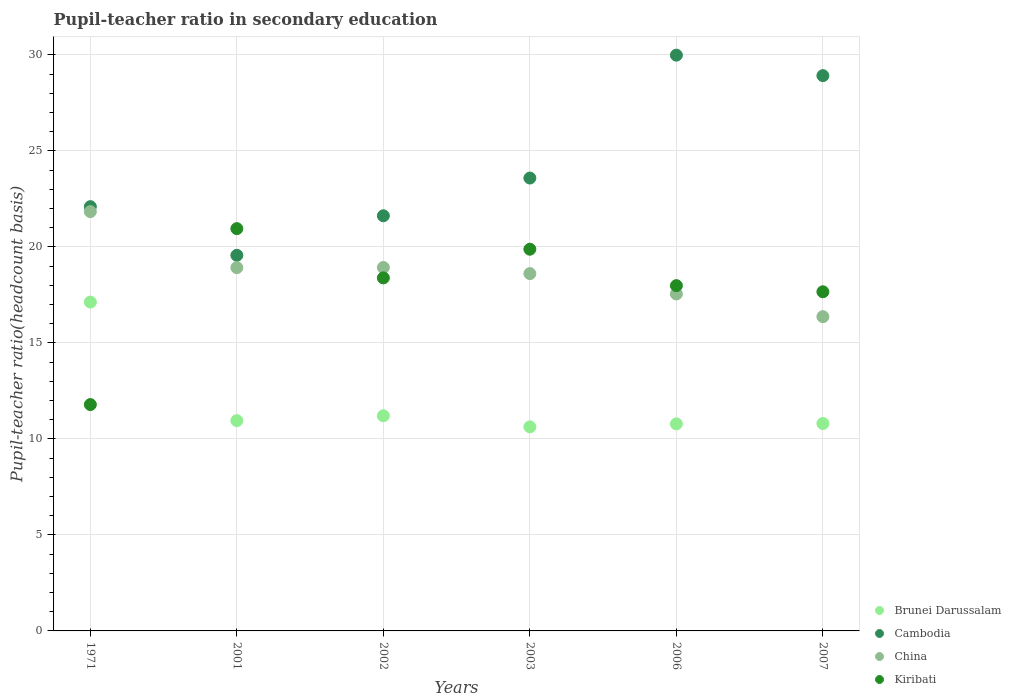Is the number of dotlines equal to the number of legend labels?
Make the answer very short. Yes. What is the pupil-teacher ratio in secondary education in Kiribati in 1971?
Ensure brevity in your answer.  11.79. Across all years, what is the maximum pupil-teacher ratio in secondary education in Cambodia?
Keep it short and to the point. 29.99. Across all years, what is the minimum pupil-teacher ratio in secondary education in China?
Offer a terse response. 16.37. What is the total pupil-teacher ratio in secondary education in Cambodia in the graph?
Ensure brevity in your answer.  145.78. What is the difference between the pupil-teacher ratio in secondary education in China in 2006 and that in 2007?
Your response must be concise. 1.18. What is the difference between the pupil-teacher ratio in secondary education in China in 2006 and the pupil-teacher ratio in secondary education in Kiribati in 1971?
Ensure brevity in your answer.  5.76. What is the average pupil-teacher ratio in secondary education in Cambodia per year?
Offer a terse response. 24.3. In the year 2003, what is the difference between the pupil-teacher ratio in secondary education in China and pupil-teacher ratio in secondary education in Cambodia?
Your answer should be compact. -4.98. In how many years, is the pupil-teacher ratio in secondary education in Cambodia greater than 24?
Provide a succinct answer. 2. What is the ratio of the pupil-teacher ratio in secondary education in Kiribati in 2001 to that in 2007?
Provide a short and direct response. 1.19. Is the pupil-teacher ratio in secondary education in China in 2001 less than that in 2007?
Provide a short and direct response. No. What is the difference between the highest and the second highest pupil-teacher ratio in secondary education in Kiribati?
Provide a succinct answer. 1.07. What is the difference between the highest and the lowest pupil-teacher ratio in secondary education in Brunei Darussalam?
Offer a very short reply. 6.5. Is the sum of the pupil-teacher ratio in secondary education in China in 2001 and 2003 greater than the maximum pupil-teacher ratio in secondary education in Kiribati across all years?
Your answer should be compact. Yes. Is it the case that in every year, the sum of the pupil-teacher ratio in secondary education in Cambodia and pupil-teacher ratio in secondary education in China  is greater than the sum of pupil-teacher ratio in secondary education in Brunei Darussalam and pupil-teacher ratio in secondary education in Kiribati?
Your answer should be very brief. No. Is the pupil-teacher ratio in secondary education in Brunei Darussalam strictly less than the pupil-teacher ratio in secondary education in Cambodia over the years?
Make the answer very short. Yes. How many years are there in the graph?
Provide a short and direct response. 6. How many legend labels are there?
Make the answer very short. 4. How are the legend labels stacked?
Provide a succinct answer. Vertical. What is the title of the graph?
Your response must be concise. Pupil-teacher ratio in secondary education. Does "Czech Republic" appear as one of the legend labels in the graph?
Your answer should be compact. No. What is the label or title of the Y-axis?
Provide a succinct answer. Pupil-teacher ratio(headcount basis). What is the Pupil-teacher ratio(headcount basis) in Brunei Darussalam in 1971?
Your answer should be compact. 17.13. What is the Pupil-teacher ratio(headcount basis) of Cambodia in 1971?
Provide a short and direct response. 22.1. What is the Pupil-teacher ratio(headcount basis) in China in 1971?
Give a very brief answer. 21.84. What is the Pupil-teacher ratio(headcount basis) of Kiribati in 1971?
Offer a terse response. 11.79. What is the Pupil-teacher ratio(headcount basis) in Brunei Darussalam in 2001?
Make the answer very short. 10.95. What is the Pupil-teacher ratio(headcount basis) of Cambodia in 2001?
Make the answer very short. 19.56. What is the Pupil-teacher ratio(headcount basis) in China in 2001?
Offer a terse response. 18.92. What is the Pupil-teacher ratio(headcount basis) of Kiribati in 2001?
Provide a short and direct response. 20.95. What is the Pupil-teacher ratio(headcount basis) in Brunei Darussalam in 2002?
Your answer should be compact. 11.21. What is the Pupil-teacher ratio(headcount basis) of Cambodia in 2002?
Provide a short and direct response. 21.62. What is the Pupil-teacher ratio(headcount basis) in China in 2002?
Ensure brevity in your answer.  18.93. What is the Pupil-teacher ratio(headcount basis) of Kiribati in 2002?
Make the answer very short. 18.39. What is the Pupil-teacher ratio(headcount basis) of Brunei Darussalam in 2003?
Provide a short and direct response. 10.63. What is the Pupil-teacher ratio(headcount basis) in Cambodia in 2003?
Provide a succinct answer. 23.59. What is the Pupil-teacher ratio(headcount basis) in China in 2003?
Offer a terse response. 18.61. What is the Pupil-teacher ratio(headcount basis) in Kiribati in 2003?
Provide a succinct answer. 19.88. What is the Pupil-teacher ratio(headcount basis) in Brunei Darussalam in 2006?
Your answer should be compact. 10.78. What is the Pupil-teacher ratio(headcount basis) of Cambodia in 2006?
Offer a very short reply. 29.99. What is the Pupil-teacher ratio(headcount basis) of China in 2006?
Your answer should be compact. 17.55. What is the Pupil-teacher ratio(headcount basis) of Kiribati in 2006?
Provide a succinct answer. 17.98. What is the Pupil-teacher ratio(headcount basis) in Brunei Darussalam in 2007?
Provide a short and direct response. 10.8. What is the Pupil-teacher ratio(headcount basis) of Cambodia in 2007?
Provide a short and direct response. 28.92. What is the Pupil-teacher ratio(headcount basis) of China in 2007?
Give a very brief answer. 16.37. What is the Pupil-teacher ratio(headcount basis) in Kiribati in 2007?
Offer a terse response. 17.66. Across all years, what is the maximum Pupil-teacher ratio(headcount basis) of Brunei Darussalam?
Your answer should be very brief. 17.13. Across all years, what is the maximum Pupil-teacher ratio(headcount basis) in Cambodia?
Provide a short and direct response. 29.99. Across all years, what is the maximum Pupil-teacher ratio(headcount basis) in China?
Your answer should be very brief. 21.84. Across all years, what is the maximum Pupil-teacher ratio(headcount basis) of Kiribati?
Make the answer very short. 20.95. Across all years, what is the minimum Pupil-teacher ratio(headcount basis) of Brunei Darussalam?
Your answer should be compact. 10.63. Across all years, what is the minimum Pupil-teacher ratio(headcount basis) of Cambodia?
Provide a succinct answer. 19.56. Across all years, what is the minimum Pupil-teacher ratio(headcount basis) of China?
Give a very brief answer. 16.37. Across all years, what is the minimum Pupil-teacher ratio(headcount basis) in Kiribati?
Your answer should be compact. 11.79. What is the total Pupil-teacher ratio(headcount basis) in Brunei Darussalam in the graph?
Your answer should be very brief. 71.5. What is the total Pupil-teacher ratio(headcount basis) in Cambodia in the graph?
Your answer should be compact. 145.78. What is the total Pupil-teacher ratio(headcount basis) in China in the graph?
Offer a very short reply. 112.22. What is the total Pupil-teacher ratio(headcount basis) of Kiribati in the graph?
Your response must be concise. 106.66. What is the difference between the Pupil-teacher ratio(headcount basis) of Brunei Darussalam in 1971 and that in 2001?
Provide a short and direct response. 6.18. What is the difference between the Pupil-teacher ratio(headcount basis) of Cambodia in 1971 and that in 2001?
Provide a short and direct response. 2.53. What is the difference between the Pupil-teacher ratio(headcount basis) in China in 1971 and that in 2001?
Your answer should be compact. 2.92. What is the difference between the Pupil-teacher ratio(headcount basis) in Kiribati in 1971 and that in 2001?
Ensure brevity in your answer.  -9.16. What is the difference between the Pupil-teacher ratio(headcount basis) of Brunei Darussalam in 1971 and that in 2002?
Give a very brief answer. 5.92. What is the difference between the Pupil-teacher ratio(headcount basis) in Cambodia in 1971 and that in 2002?
Offer a very short reply. 0.47. What is the difference between the Pupil-teacher ratio(headcount basis) of China in 1971 and that in 2002?
Your answer should be very brief. 2.91. What is the difference between the Pupil-teacher ratio(headcount basis) in Kiribati in 1971 and that in 2002?
Provide a succinct answer. -6.6. What is the difference between the Pupil-teacher ratio(headcount basis) of Brunei Darussalam in 1971 and that in 2003?
Keep it short and to the point. 6.5. What is the difference between the Pupil-teacher ratio(headcount basis) in Cambodia in 1971 and that in 2003?
Your answer should be compact. -1.49. What is the difference between the Pupil-teacher ratio(headcount basis) of China in 1971 and that in 2003?
Make the answer very short. 3.23. What is the difference between the Pupil-teacher ratio(headcount basis) in Kiribati in 1971 and that in 2003?
Your answer should be very brief. -8.09. What is the difference between the Pupil-teacher ratio(headcount basis) in Brunei Darussalam in 1971 and that in 2006?
Your answer should be compact. 6.34. What is the difference between the Pupil-teacher ratio(headcount basis) of Cambodia in 1971 and that in 2006?
Make the answer very short. -7.89. What is the difference between the Pupil-teacher ratio(headcount basis) of China in 1971 and that in 2006?
Offer a very short reply. 4.29. What is the difference between the Pupil-teacher ratio(headcount basis) of Kiribati in 1971 and that in 2006?
Your answer should be very brief. -6.19. What is the difference between the Pupil-teacher ratio(headcount basis) of Brunei Darussalam in 1971 and that in 2007?
Keep it short and to the point. 6.32. What is the difference between the Pupil-teacher ratio(headcount basis) in Cambodia in 1971 and that in 2007?
Offer a very short reply. -6.82. What is the difference between the Pupil-teacher ratio(headcount basis) of China in 1971 and that in 2007?
Give a very brief answer. 5.47. What is the difference between the Pupil-teacher ratio(headcount basis) in Kiribati in 1971 and that in 2007?
Keep it short and to the point. -5.88. What is the difference between the Pupil-teacher ratio(headcount basis) of Brunei Darussalam in 2001 and that in 2002?
Your answer should be compact. -0.25. What is the difference between the Pupil-teacher ratio(headcount basis) in Cambodia in 2001 and that in 2002?
Provide a short and direct response. -2.06. What is the difference between the Pupil-teacher ratio(headcount basis) of China in 2001 and that in 2002?
Provide a short and direct response. -0.01. What is the difference between the Pupil-teacher ratio(headcount basis) of Kiribati in 2001 and that in 2002?
Make the answer very short. 2.57. What is the difference between the Pupil-teacher ratio(headcount basis) of Brunei Darussalam in 2001 and that in 2003?
Your answer should be very brief. 0.32. What is the difference between the Pupil-teacher ratio(headcount basis) in Cambodia in 2001 and that in 2003?
Offer a terse response. -4.02. What is the difference between the Pupil-teacher ratio(headcount basis) in China in 2001 and that in 2003?
Keep it short and to the point. 0.31. What is the difference between the Pupil-teacher ratio(headcount basis) in Kiribati in 2001 and that in 2003?
Make the answer very short. 1.07. What is the difference between the Pupil-teacher ratio(headcount basis) in Brunei Darussalam in 2001 and that in 2006?
Ensure brevity in your answer.  0.17. What is the difference between the Pupil-teacher ratio(headcount basis) of Cambodia in 2001 and that in 2006?
Keep it short and to the point. -10.42. What is the difference between the Pupil-teacher ratio(headcount basis) in China in 2001 and that in 2006?
Give a very brief answer. 1.37. What is the difference between the Pupil-teacher ratio(headcount basis) in Kiribati in 2001 and that in 2006?
Keep it short and to the point. 2.97. What is the difference between the Pupil-teacher ratio(headcount basis) of Brunei Darussalam in 2001 and that in 2007?
Provide a short and direct response. 0.15. What is the difference between the Pupil-teacher ratio(headcount basis) in Cambodia in 2001 and that in 2007?
Offer a terse response. -9.36. What is the difference between the Pupil-teacher ratio(headcount basis) in China in 2001 and that in 2007?
Ensure brevity in your answer.  2.55. What is the difference between the Pupil-teacher ratio(headcount basis) of Kiribati in 2001 and that in 2007?
Your answer should be compact. 3.29. What is the difference between the Pupil-teacher ratio(headcount basis) of Brunei Darussalam in 2002 and that in 2003?
Your answer should be very brief. 0.58. What is the difference between the Pupil-teacher ratio(headcount basis) of Cambodia in 2002 and that in 2003?
Provide a short and direct response. -1.97. What is the difference between the Pupil-teacher ratio(headcount basis) of China in 2002 and that in 2003?
Offer a terse response. 0.32. What is the difference between the Pupil-teacher ratio(headcount basis) of Kiribati in 2002 and that in 2003?
Provide a short and direct response. -1.49. What is the difference between the Pupil-teacher ratio(headcount basis) in Brunei Darussalam in 2002 and that in 2006?
Provide a short and direct response. 0.42. What is the difference between the Pupil-teacher ratio(headcount basis) in Cambodia in 2002 and that in 2006?
Your response must be concise. -8.37. What is the difference between the Pupil-teacher ratio(headcount basis) in China in 2002 and that in 2006?
Provide a short and direct response. 1.38. What is the difference between the Pupil-teacher ratio(headcount basis) of Kiribati in 2002 and that in 2006?
Provide a short and direct response. 0.4. What is the difference between the Pupil-teacher ratio(headcount basis) of Brunei Darussalam in 2002 and that in 2007?
Your response must be concise. 0.4. What is the difference between the Pupil-teacher ratio(headcount basis) of Cambodia in 2002 and that in 2007?
Provide a short and direct response. -7.3. What is the difference between the Pupil-teacher ratio(headcount basis) of China in 2002 and that in 2007?
Give a very brief answer. 2.56. What is the difference between the Pupil-teacher ratio(headcount basis) in Kiribati in 2002 and that in 2007?
Your response must be concise. 0.72. What is the difference between the Pupil-teacher ratio(headcount basis) of Brunei Darussalam in 2003 and that in 2006?
Offer a very short reply. -0.15. What is the difference between the Pupil-teacher ratio(headcount basis) in Cambodia in 2003 and that in 2006?
Ensure brevity in your answer.  -6.4. What is the difference between the Pupil-teacher ratio(headcount basis) in China in 2003 and that in 2006?
Give a very brief answer. 1.06. What is the difference between the Pupil-teacher ratio(headcount basis) in Kiribati in 2003 and that in 2006?
Ensure brevity in your answer.  1.9. What is the difference between the Pupil-teacher ratio(headcount basis) in Brunei Darussalam in 2003 and that in 2007?
Provide a succinct answer. -0.17. What is the difference between the Pupil-teacher ratio(headcount basis) in Cambodia in 2003 and that in 2007?
Give a very brief answer. -5.33. What is the difference between the Pupil-teacher ratio(headcount basis) of China in 2003 and that in 2007?
Your answer should be compact. 2.24. What is the difference between the Pupil-teacher ratio(headcount basis) of Kiribati in 2003 and that in 2007?
Your response must be concise. 2.22. What is the difference between the Pupil-teacher ratio(headcount basis) of Brunei Darussalam in 2006 and that in 2007?
Offer a very short reply. -0.02. What is the difference between the Pupil-teacher ratio(headcount basis) of Cambodia in 2006 and that in 2007?
Provide a short and direct response. 1.07. What is the difference between the Pupil-teacher ratio(headcount basis) in China in 2006 and that in 2007?
Your response must be concise. 1.18. What is the difference between the Pupil-teacher ratio(headcount basis) in Kiribati in 2006 and that in 2007?
Your answer should be very brief. 0.32. What is the difference between the Pupil-teacher ratio(headcount basis) in Brunei Darussalam in 1971 and the Pupil-teacher ratio(headcount basis) in Cambodia in 2001?
Your answer should be very brief. -2.44. What is the difference between the Pupil-teacher ratio(headcount basis) of Brunei Darussalam in 1971 and the Pupil-teacher ratio(headcount basis) of China in 2001?
Make the answer very short. -1.8. What is the difference between the Pupil-teacher ratio(headcount basis) in Brunei Darussalam in 1971 and the Pupil-teacher ratio(headcount basis) in Kiribati in 2001?
Your answer should be compact. -3.83. What is the difference between the Pupil-teacher ratio(headcount basis) of Cambodia in 1971 and the Pupil-teacher ratio(headcount basis) of China in 2001?
Your answer should be very brief. 3.17. What is the difference between the Pupil-teacher ratio(headcount basis) of Cambodia in 1971 and the Pupil-teacher ratio(headcount basis) of Kiribati in 2001?
Your answer should be very brief. 1.14. What is the difference between the Pupil-teacher ratio(headcount basis) of China in 1971 and the Pupil-teacher ratio(headcount basis) of Kiribati in 2001?
Make the answer very short. 0.89. What is the difference between the Pupil-teacher ratio(headcount basis) of Brunei Darussalam in 1971 and the Pupil-teacher ratio(headcount basis) of Cambodia in 2002?
Your response must be concise. -4.5. What is the difference between the Pupil-teacher ratio(headcount basis) of Brunei Darussalam in 1971 and the Pupil-teacher ratio(headcount basis) of China in 2002?
Keep it short and to the point. -1.8. What is the difference between the Pupil-teacher ratio(headcount basis) of Brunei Darussalam in 1971 and the Pupil-teacher ratio(headcount basis) of Kiribati in 2002?
Your answer should be compact. -1.26. What is the difference between the Pupil-teacher ratio(headcount basis) of Cambodia in 1971 and the Pupil-teacher ratio(headcount basis) of China in 2002?
Provide a succinct answer. 3.17. What is the difference between the Pupil-teacher ratio(headcount basis) in Cambodia in 1971 and the Pupil-teacher ratio(headcount basis) in Kiribati in 2002?
Your answer should be compact. 3.71. What is the difference between the Pupil-teacher ratio(headcount basis) of China in 1971 and the Pupil-teacher ratio(headcount basis) of Kiribati in 2002?
Make the answer very short. 3.45. What is the difference between the Pupil-teacher ratio(headcount basis) in Brunei Darussalam in 1971 and the Pupil-teacher ratio(headcount basis) in Cambodia in 2003?
Provide a succinct answer. -6.46. What is the difference between the Pupil-teacher ratio(headcount basis) of Brunei Darussalam in 1971 and the Pupil-teacher ratio(headcount basis) of China in 2003?
Provide a short and direct response. -1.48. What is the difference between the Pupil-teacher ratio(headcount basis) of Brunei Darussalam in 1971 and the Pupil-teacher ratio(headcount basis) of Kiribati in 2003?
Ensure brevity in your answer.  -2.75. What is the difference between the Pupil-teacher ratio(headcount basis) in Cambodia in 1971 and the Pupil-teacher ratio(headcount basis) in China in 2003?
Your answer should be very brief. 3.49. What is the difference between the Pupil-teacher ratio(headcount basis) in Cambodia in 1971 and the Pupil-teacher ratio(headcount basis) in Kiribati in 2003?
Give a very brief answer. 2.22. What is the difference between the Pupil-teacher ratio(headcount basis) in China in 1971 and the Pupil-teacher ratio(headcount basis) in Kiribati in 2003?
Offer a very short reply. 1.96. What is the difference between the Pupil-teacher ratio(headcount basis) in Brunei Darussalam in 1971 and the Pupil-teacher ratio(headcount basis) in Cambodia in 2006?
Keep it short and to the point. -12.86. What is the difference between the Pupil-teacher ratio(headcount basis) in Brunei Darussalam in 1971 and the Pupil-teacher ratio(headcount basis) in China in 2006?
Offer a very short reply. -0.42. What is the difference between the Pupil-teacher ratio(headcount basis) of Brunei Darussalam in 1971 and the Pupil-teacher ratio(headcount basis) of Kiribati in 2006?
Make the answer very short. -0.86. What is the difference between the Pupil-teacher ratio(headcount basis) of Cambodia in 1971 and the Pupil-teacher ratio(headcount basis) of China in 2006?
Offer a very short reply. 4.55. What is the difference between the Pupil-teacher ratio(headcount basis) of Cambodia in 1971 and the Pupil-teacher ratio(headcount basis) of Kiribati in 2006?
Your answer should be very brief. 4.11. What is the difference between the Pupil-teacher ratio(headcount basis) of China in 1971 and the Pupil-teacher ratio(headcount basis) of Kiribati in 2006?
Ensure brevity in your answer.  3.86. What is the difference between the Pupil-teacher ratio(headcount basis) of Brunei Darussalam in 1971 and the Pupil-teacher ratio(headcount basis) of Cambodia in 2007?
Your answer should be very brief. -11.79. What is the difference between the Pupil-teacher ratio(headcount basis) of Brunei Darussalam in 1971 and the Pupil-teacher ratio(headcount basis) of China in 2007?
Offer a very short reply. 0.76. What is the difference between the Pupil-teacher ratio(headcount basis) of Brunei Darussalam in 1971 and the Pupil-teacher ratio(headcount basis) of Kiribati in 2007?
Keep it short and to the point. -0.54. What is the difference between the Pupil-teacher ratio(headcount basis) of Cambodia in 1971 and the Pupil-teacher ratio(headcount basis) of China in 2007?
Offer a terse response. 5.73. What is the difference between the Pupil-teacher ratio(headcount basis) in Cambodia in 1971 and the Pupil-teacher ratio(headcount basis) in Kiribati in 2007?
Your response must be concise. 4.43. What is the difference between the Pupil-teacher ratio(headcount basis) in China in 1971 and the Pupil-teacher ratio(headcount basis) in Kiribati in 2007?
Provide a short and direct response. 4.17. What is the difference between the Pupil-teacher ratio(headcount basis) of Brunei Darussalam in 2001 and the Pupil-teacher ratio(headcount basis) of Cambodia in 2002?
Ensure brevity in your answer.  -10.67. What is the difference between the Pupil-teacher ratio(headcount basis) of Brunei Darussalam in 2001 and the Pupil-teacher ratio(headcount basis) of China in 2002?
Provide a short and direct response. -7.98. What is the difference between the Pupil-teacher ratio(headcount basis) of Brunei Darussalam in 2001 and the Pupil-teacher ratio(headcount basis) of Kiribati in 2002?
Your response must be concise. -7.44. What is the difference between the Pupil-teacher ratio(headcount basis) of Cambodia in 2001 and the Pupil-teacher ratio(headcount basis) of China in 2002?
Offer a very short reply. 0.63. What is the difference between the Pupil-teacher ratio(headcount basis) of Cambodia in 2001 and the Pupil-teacher ratio(headcount basis) of Kiribati in 2002?
Offer a terse response. 1.18. What is the difference between the Pupil-teacher ratio(headcount basis) in China in 2001 and the Pupil-teacher ratio(headcount basis) in Kiribati in 2002?
Offer a terse response. 0.54. What is the difference between the Pupil-teacher ratio(headcount basis) in Brunei Darussalam in 2001 and the Pupil-teacher ratio(headcount basis) in Cambodia in 2003?
Make the answer very short. -12.64. What is the difference between the Pupil-teacher ratio(headcount basis) of Brunei Darussalam in 2001 and the Pupil-teacher ratio(headcount basis) of China in 2003?
Your answer should be compact. -7.66. What is the difference between the Pupil-teacher ratio(headcount basis) in Brunei Darussalam in 2001 and the Pupil-teacher ratio(headcount basis) in Kiribati in 2003?
Make the answer very short. -8.93. What is the difference between the Pupil-teacher ratio(headcount basis) of Cambodia in 2001 and the Pupil-teacher ratio(headcount basis) of China in 2003?
Provide a short and direct response. 0.95. What is the difference between the Pupil-teacher ratio(headcount basis) in Cambodia in 2001 and the Pupil-teacher ratio(headcount basis) in Kiribati in 2003?
Give a very brief answer. -0.32. What is the difference between the Pupil-teacher ratio(headcount basis) of China in 2001 and the Pupil-teacher ratio(headcount basis) of Kiribati in 2003?
Your answer should be very brief. -0.96. What is the difference between the Pupil-teacher ratio(headcount basis) of Brunei Darussalam in 2001 and the Pupil-teacher ratio(headcount basis) of Cambodia in 2006?
Keep it short and to the point. -19.04. What is the difference between the Pupil-teacher ratio(headcount basis) in Brunei Darussalam in 2001 and the Pupil-teacher ratio(headcount basis) in China in 2006?
Provide a short and direct response. -6.6. What is the difference between the Pupil-teacher ratio(headcount basis) of Brunei Darussalam in 2001 and the Pupil-teacher ratio(headcount basis) of Kiribati in 2006?
Offer a terse response. -7.03. What is the difference between the Pupil-teacher ratio(headcount basis) of Cambodia in 2001 and the Pupil-teacher ratio(headcount basis) of China in 2006?
Keep it short and to the point. 2.01. What is the difference between the Pupil-teacher ratio(headcount basis) of Cambodia in 2001 and the Pupil-teacher ratio(headcount basis) of Kiribati in 2006?
Your response must be concise. 1.58. What is the difference between the Pupil-teacher ratio(headcount basis) of China in 2001 and the Pupil-teacher ratio(headcount basis) of Kiribati in 2006?
Offer a terse response. 0.94. What is the difference between the Pupil-teacher ratio(headcount basis) of Brunei Darussalam in 2001 and the Pupil-teacher ratio(headcount basis) of Cambodia in 2007?
Provide a succinct answer. -17.97. What is the difference between the Pupil-teacher ratio(headcount basis) of Brunei Darussalam in 2001 and the Pupil-teacher ratio(headcount basis) of China in 2007?
Your answer should be very brief. -5.42. What is the difference between the Pupil-teacher ratio(headcount basis) of Brunei Darussalam in 2001 and the Pupil-teacher ratio(headcount basis) of Kiribati in 2007?
Ensure brevity in your answer.  -6.71. What is the difference between the Pupil-teacher ratio(headcount basis) in Cambodia in 2001 and the Pupil-teacher ratio(headcount basis) in China in 2007?
Your answer should be compact. 3.2. What is the difference between the Pupil-teacher ratio(headcount basis) in Cambodia in 2001 and the Pupil-teacher ratio(headcount basis) in Kiribati in 2007?
Your answer should be very brief. 1.9. What is the difference between the Pupil-teacher ratio(headcount basis) in China in 2001 and the Pupil-teacher ratio(headcount basis) in Kiribati in 2007?
Provide a succinct answer. 1.26. What is the difference between the Pupil-teacher ratio(headcount basis) of Brunei Darussalam in 2002 and the Pupil-teacher ratio(headcount basis) of Cambodia in 2003?
Make the answer very short. -12.38. What is the difference between the Pupil-teacher ratio(headcount basis) in Brunei Darussalam in 2002 and the Pupil-teacher ratio(headcount basis) in China in 2003?
Offer a very short reply. -7.41. What is the difference between the Pupil-teacher ratio(headcount basis) in Brunei Darussalam in 2002 and the Pupil-teacher ratio(headcount basis) in Kiribati in 2003?
Provide a succinct answer. -8.68. What is the difference between the Pupil-teacher ratio(headcount basis) in Cambodia in 2002 and the Pupil-teacher ratio(headcount basis) in China in 2003?
Provide a short and direct response. 3.01. What is the difference between the Pupil-teacher ratio(headcount basis) of Cambodia in 2002 and the Pupil-teacher ratio(headcount basis) of Kiribati in 2003?
Offer a terse response. 1.74. What is the difference between the Pupil-teacher ratio(headcount basis) of China in 2002 and the Pupil-teacher ratio(headcount basis) of Kiribati in 2003?
Provide a short and direct response. -0.95. What is the difference between the Pupil-teacher ratio(headcount basis) of Brunei Darussalam in 2002 and the Pupil-teacher ratio(headcount basis) of Cambodia in 2006?
Your answer should be compact. -18.78. What is the difference between the Pupil-teacher ratio(headcount basis) of Brunei Darussalam in 2002 and the Pupil-teacher ratio(headcount basis) of China in 2006?
Your answer should be very brief. -6.34. What is the difference between the Pupil-teacher ratio(headcount basis) in Brunei Darussalam in 2002 and the Pupil-teacher ratio(headcount basis) in Kiribati in 2006?
Offer a terse response. -6.78. What is the difference between the Pupil-teacher ratio(headcount basis) in Cambodia in 2002 and the Pupil-teacher ratio(headcount basis) in China in 2006?
Your answer should be very brief. 4.07. What is the difference between the Pupil-teacher ratio(headcount basis) of Cambodia in 2002 and the Pupil-teacher ratio(headcount basis) of Kiribati in 2006?
Your answer should be compact. 3.64. What is the difference between the Pupil-teacher ratio(headcount basis) in China in 2002 and the Pupil-teacher ratio(headcount basis) in Kiribati in 2006?
Give a very brief answer. 0.94. What is the difference between the Pupil-teacher ratio(headcount basis) of Brunei Darussalam in 2002 and the Pupil-teacher ratio(headcount basis) of Cambodia in 2007?
Your answer should be compact. -17.72. What is the difference between the Pupil-teacher ratio(headcount basis) of Brunei Darussalam in 2002 and the Pupil-teacher ratio(headcount basis) of China in 2007?
Offer a very short reply. -5.16. What is the difference between the Pupil-teacher ratio(headcount basis) of Brunei Darussalam in 2002 and the Pupil-teacher ratio(headcount basis) of Kiribati in 2007?
Provide a succinct answer. -6.46. What is the difference between the Pupil-teacher ratio(headcount basis) of Cambodia in 2002 and the Pupil-teacher ratio(headcount basis) of China in 2007?
Your answer should be very brief. 5.25. What is the difference between the Pupil-teacher ratio(headcount basis) in Cambodia in 2002 and the Pupil-teacher ratio(headcount basis) in Kiribati in 2007?
Provide a succinct answer. 3.96. What is the difference between the Pupil-teacher ratio(headcount basis) in China in 2002 and the Pupil-teacher ratio(headcount basis) in Kiribati in 2007?
Your answer should be very brief. 1.26. What is the difference between the Pupil-teacher ratio(headcount basis) of Brunei Darussalam in 2003 and the Pupil-teacher ratio(headcount basis) of Cambodia in 2006?
Provide a succinct answer. -19.36. What is the difference between the Pupil-teacher ratio(headcount basis) in Brunei Darussalam in 2003 and the Pupil-teacher ratio(headcount basis) in China in 2006?
Provide a short and direct response. -6.92. What is the difference between the Pupil-teacher ratio(headcount basis) in Brunei Darussalam in 2003 and the Pupil-teacher ratio(headcount basis) in Kiribati in 2006?
Offer a very short reply. -7.35. What is the difference between the Pupil-teacher ratio(headcount basis) in Cambodia in 2003 and the Pupil-teacher ratio(headcount basis) in China in 2006?
Your answer should be compact. 6.04. What is the difference between the Pupil-teacher ratio(headcount basis) of Cambodia in 2003 and the Pupil-teacher ratio(headcount basis) of Kiribati in 2006?
Offer a very short reply. 5.6. What is the difference between the Pupil-teacher ratio(headcount basis) of China in 2003 and the Pupil-teacher ratio(headcount basis) of Kiribati in 2006?
Provide a succinct answer. 0.63. What is the difference between the Pupil-teacher ratio(headcount basis) in Brunei Darussalam in 2003 and the Pupil-teacher ratio(headcount basis) in Cambodia in 2007?
Provide a short and direct response. -18.29. What is the difference between the Pupil-teacher ratio(headcount basis) of Brunei Darussalam in 2003 and the Pupil-teacher ratio(headcount basis) of China in 2007?
Ensure brevity in your answer.  -5.74. What is the difference between the Pupil-teacher ratio(headcount basis) in Brunei Darussalam in 2003 and the Pupil-teacher ratio(headcount basis) in Kiribati in 2007?
Offer a very short reply. -7.03. What is the difference between the Pupil-teacher ratio(headcount basis) of Cambodia in 2003 and the Pupil-teacher ratio(headcount basis) of China in 2007?
Your answer should be compact. 7.22. What is the difference between the Pupil-teacher ratio(headcount basis) of Cambodia in 2003 and the Pupil-teacher ratio(headcount basis) of Kiribati in 2007?
Give a very brief answer. 5.92. What is the difference between the Pupil-teacher ratio(headcount basis) of China in 2003 and the Pupil-teacher ratio(headcount basis) of Kiribati in 2007?
Provide a succinct answer. 0.95. What is the difference between the Pupil-teacher ratio(headcount basis) in Brunei Darussalam in 2006 and the Pupil-teacher ratio(headcount basis) in Cambodia in 2007?
Your answer should be very brief. -18.14. What is the difference between the Pupil-teacher ratio(headcount basis) in Brunei Darussalam in 2006 and the Pupil-teacher ratio(headcount basis) in China in 2007?
Ensure brevity in your answer.  -5.58. What is the difference between the Pupil-teacher ratio(headcount basis) in Brunei Darussalam in 2006 and the Pupil-teacher ratio(headcount basis) in Kiribati in 2007?
Offer a terse response. -6.88. What is the difference between the Pupil-teacher ratio(headcount basis) in Cambodia in 2006 and the Pupil-teacher ratio(headcount basis) in China in 2007?
Give a very brief answer. 13.62. What is the difference between the Pupil-teacher ratio(headcount basis) in Cambodia in 2006 and the Pupil-teacher ratio(headcount basis) in Kiribati in 2007?
Ensure brevity in your answer.  12.32. What is the difference between the Pupil-teacher ratio(headcount basis) of China in 2006 and the Pupil-teacher ratio(headcount basis) of Kiribati in 2007?
Ensure brevity in your answer.  -0.12. What is the average Pupil-teacher ratio(headcount basis) of Brunei Darussalam per year?
Give a very brief answer. 11.92. What is the average Pupil-teacher ratio(headcount basis) in Cambodia per year?
Provide a succinct answer. 24.3. What is the average Pupil-teacher ratio(headcount basis) in China per year?
Your answer should be compact. 18.7. What is the average Pupil-teacher ratio(headcount basis) in Kiribati per year?
Offer a terse response. 17.78. In the year 1971, what is the difference between the Pupil-teacher ratio(headcount basis) of Brunei Darussalam and Pupil-teacher ratio(headcount basis) of Cambodia?
Your answer should be very brief. -4.97. In the year 1971, what is the difference between the Pupil-teacher ratio(headcount basis) in Brunei Darussalam and Pupil-teacher ratio(headcount basis) in China?
Provide a succinct answer. -4.71. In the year 1971, what is the difference between the Pupil-teacher ratio(headcount basis) of Brunei Darussalam and Pupil-teacher ratio(headcount basis) of Kiribati?
Give a very brief answer. 5.34. In the year 1971, what is the difference between the Pupil-teacher ratio(headcount basis) in Cambodia and Pupil-teacher ratio(headcount basis) in China?
Ensure brevity in your answer.  0.26. In the year 1971, what is the difference between the Pupil-teacher ratio(headcount basis) in Cambodia and Pupil-teacher ratio(headcount basis) in Kiribati?
Provide a short and direct response. 10.31. In the year 1971, what is the difference between the Pupil-teacher ratio(headcount basis) in China and Pupil-teacher ratio(headcount basis) in Kiribati?
Give a very brief answer. 10.05. In the year 2001, what is the difference between the Pupil-teacher ratio(headcount basis) in Brunei Darussalam and Pupil-teacher ratio(headcount basis) in Cambodia?
Your response must be concise. -8.61. In the year 2001, what is the difference between the Pupil-teacher ratio(headcount basis) of Brunei Darussalam and Pupil-teacher ratio(headcount basis) of China?
Make the answer very short. -7.97. In the year 2001, what is the difference between the Pupil-teacher ratio(headcount basis) in Brunei Darussalam and Pupil-teacher ratio(headcount basis) in Kiribati?
Your answer should be compact. -10. In the year 2001, what is the difference between the Pupil-teacher ratio(headcount basis) of Cambodia and Pupil-teacher ratio(headcount basis) of China?
Make the answer very short. 0.64. In the year 2001, what is the difference between the Pupil-teacher ratio(headcount basis) of Cambodia and Pupil-teacher ratio(headcount basis) of Kiribati?
Your answer should be compact. -1.39. In the year 2001, what is the difference between the Pupil-teacher ratio(headcount basis) of China and Pupil-teacher ratio(headcount basis) of Kiribati?
Provide a short and direct response. -2.03. In the year 2002, what is the difference between the Pupil-teacher ratio(headcount basis) in Brunei Darussalam and Pupil-teacher ratio(headcount basis) in Cambodia?
Your answer should be very brief. -10.42. In the year 2002, what is the difference between the Pupil-teacher ratio(headcount basis) of Brunei Darussalam and Pupil-teacher ratio(headcount basis) of China?
Offer a terse response. -7.72. In the year 2002, what is the difference between the Pupil-teacher ratio(headcount basis) in Brunei Darussalam and Pupil-teacher ratio(headcount basis) in Kiribati?
Make the answer very short. -7.18. In the year 2002, what is the difference between the Pupil-teacher ratio(headcount basis) in Cambodia and Pupil-teacher ratio(headcount basis) in China?
Offer a very short reply. 2.69. In the year 2002, what is the difference between the Pupil-teacher ratio(headcount basis) in Cambodia and Pupil-teacher ratio(headcount basis) in Kiribati?
Make the answer very short. 3.23. In the year 2002, what is the difference between the Pupil-teacher ratio(headcount basis) in China and Pupil-teacher ratio(headcount basis) in Kiribati?
Ensure brevity in your answer.  0.54. In the year 2003, what is the difference between the Pupil-teacher ratio(headcount basis) of Brunei Darussalam and Pupil-teacher ratio(headcount basis) of Cambodia?
Ensure brevity in your answer.  -12.96. In the year 2003, what is the difference between the Pupil-teacher ratio(headcount basis) of Brunei Darussalam and Pupil-teacher ratio(headcount basis) of China?
Offer a very short reply. -7.98. In the year 2003, what is the difference between the Pupil-teacher ratio(headcount basis) in Brunei Darussalam and Pupil-teacher ratio(headcount basis) in Kiribati?
Your answer should be very brief. -9.25. In the year 2003, what is the difference between the Pupil-teacher ratio(headcount basis) in Cambodia and Pupil-teacher ratio(headcount basis) in China?
Give a very brief answer. 4.98. In the year 2003, what is the difference between the Pupil-teacher ratio(headcount basis) of Cambodia and Pupil-teacher ratio(headcount basis) of Kiribati?
Offer a very short reply. 3.71. In the year 2003, what is the difference between the Pupil-teacher ratio(headcount basis) in China and Pupil-teacher ratio(headcount basis) in Kiribati?
Provide a succinct answer. -1.27. In the year 2006, what is the difference between the Pupil-teacher ratio(headcount basis) of Brunei Darussalam and Pupil-teacher ratio(headcount basis) of Cambodia?
Ensure brevity in your answer.  -19.2. In the year 2006, what is the difference between the Pupil-teacher ratio(headcount basis) in Brunei Darussalam and Pupil-teacher ratio(headcount basis) in China?
Provide a short and direct response. -6.77. In the year 2006, what is the difference between the Pupil-teacher ratio(headcount basis) in Brunei Darussalam and Pupil-teacher ratio(headcount basis) in Kiribati?
Keep it short and to the point. -7.2. In the year 2006, what is the difference between the Pupil-teacher ratio(headcount basis) of Cambodia and Pupil-teacher ratio(headcount basis) of China?
Your answer should be very brief. 12.44. In the year 2006, what is the difference between the Pupil-teacher ratio(headcount basis) in Cambodia and Pupil-teacher ratio(headcount basis) in Kiribati?
Ensure brevity in your answer.  12. In the year 2006, what is the difference between the Pupil-teacher ratio(headcount basis) in China and Pupil-teacher ratio(headcount basis) in Kiribati?
Make the answer very short. -0.43. In the year 2007, what is the difference between the Pupil-teacher ratio(headcount basis) in Brunei Darussalam and Pupil-teacher ratio(headcount basis) in Cambodia?
Make the answer very short. -18.12. In the year 2007, what is the difference between the Pupil-teacher ratio(headcount basis) of Brunei Darussalam and Pupil-teacher ratio(headcount basis) of China?
Offer a terse response. -5.57. In the year 2007, what is the difference between the Pupil-teacher ratio(headcount basis) of Brunei Darussalam and Pupil-teacher ratio(headcount basis) of Kiribati?
Your answer should be compact. -6.86. In the year 2007, what is the difference between the Pupil-teacher ratio(headcount basis) of Cambodia and Pupil-teacher ratio(headcount basis) of China?
Your answer should be very brief. 12.55. In the year 2007, what is the difference between the Pupil-teacher ratio(headcount basis) in Cambodia and Pupil-teacher ratio(headcount basis) in Kiribati?
Offer a very short reply. 11.26. In the year 2007, what is the difference between the Pupil-teacher ratio(headcount basis) of China and Pupil-teacher ratio(headcount basis) of Kiribati?
Offer a very short reply. -1.3. What is the ratio of the Pupil-teacher ratio(headcount basis) of Brunei Darussalam in 1971 to that in 2001?
Ensure brevity in your answer.  1.56. What is the ratio of the Pupil-teacher ratio(headcount basis) of Cambodia in 1971 to that in 2001?
Provide a succinct answer. 1.13. What is the ratio of the Pupil-teacher ratio(headcount basis) of China in 1971 to that in 2001?
Your answer should be very brief. 1.15. What is the ratio of the Pupil-teacher ratio(headcount basis) of Kiribati in 1971 to that in 2001?
Offer a very short reply. 0.56. What is the ratio of the Pupil-teacher ratio(headcount basis) of Brunei Darussalam in 1971 to that in 2002?
Your answer should be compact. 1.53. What is the ratio of the Pupil-teacher ratio(headcount basis) of Cambodia in 1971 to that in 2002?
Your answer should be very brief. 1.02. What is the ratio of the Pupil-teacher ratio(headcount basis) of China in 1971 to that in 2002?
Make the answer very short. 1.15. What is the ratio of the Pupil-teacher ratio(headcount basis) of Kiribati in 1971 to that in 2002?
Ensure brevity in your answer.  0.64. What is the ratio of the Pupil-teacher ratio(headcount basis) of Brunei Darussalam in 1971 to that in 2003?
Provide a succinct answer. 1.61. What is the ratio of the Pupil-teacher ratio(headcount basis) of Cambodia in 1971 to that in 2003?
Make the answer very short. 0.94. What is the ratio of the Pupil-teacher ratio(headcount basis) in China in 1971 to that in 2003?
Offer a very short reply. 1.17. What is the ratio of the Pupil-teacher ratio(headcount basis) in Kiribati in 1971 to that in 2003?
Your answer should be compact. 0.59. What is the ratio of the Pupil-teacher ratio(headcount basis) in Brunei Darussalam in 1971 to that in 2006?
Ensure brevity in your answer.  1.59. What is the ratio of the Pupil-teacher ratio(headcount basis) of Cambodia in 1971 to that in 2006?
Your answer should be compact. 0.74. What is the ratio of the Pupil-teacher ratio(headcount basis) in China in 1971 to that in 2006?
Your response must be concise. 1.24. What is the ratio of the Pupil-teacher ratio(headcount basis) in Kiribati in 1971 to that in 2006?
Make the answer very short. 0.66. What is the ratio of the Pupil-teacher ratio(headcount basis) of Brunei Darussalam in 1971 to that in 2007?
Your answer should be very brief. 1.59. What is the ratio of the Pupil-teacher ratio(headcount basis) in Cambodia in 1971 to that in 2007?
Offer a terse response. 0.76. What is the ratio of the Pupil-teacher ratio(headcount basis) in China in 1971 to that in 2007?
Keep it short and to the point. 1.33. What is the ratio of the Pupil-teacher ratio(headcount basis) in Kiribati in 1971 to that in 2007?
Ensure brevity in your answer.  0.67. What is the ratio of the Pupil-teacher ratio(headcount basis) in Brunei Darussalam in 2001 to that in 2002?
Provide a short and direct response. 0.98. What is the ratio of the Pupil-teacher ratio(headcount basis) in Cambodia in 2001 to that in 2002?
Provide a succinct answer. 0.9. What is the ratio of the Pupil-teacher ratio(headcount basis) of China in 2001 to that in 2002?
Offer a very short reply. 1. What is the ratio of the Pupil-teacher ratio(headcount basis) in Kiribati in 2001 to that in 2002?
Your answer should be very brief. 1.14. What is the ratio of the Pupil-teacher ratio(headcount basis) in Brunei Darussalam in 2001 to that in 2003?
Make the answer very short. 1.03. What is the ratio of the Pupil-teacher ratio(headcount basis) of Cambodia in 2001 to that in 2003?
Provide a succinct answer. 0.83. What is the ratio of the Pupil-teacher ratio(headcount basis) of China in 2001 to that in 2003?
Your response must be concise. 1.02. What is the ratio of the Pupil-teacher ratio(headcount basis) of Kiribati in 2001 to that in 2003?
Ensure brevity in your answer.  1.05. What is the ratio of the Pupil-teacher ratio(headcount basis) of Brunei Darussalam in 2001 to that in 2006?
Your response must be concise. 1.02. What is the ratio of the Pupil-teacher ratio(headcount basis) in Cambodia in 2001 to that in 2006?
Your response must be concise. 0.65. What is the ratio of the Pupil-teacher ratio(headcount basis) in China in 2001 to that in 2006?
Provide a short and direct response. 1.08. What is the ratio of the Pupil-teacher ratio(headcount basis) of Kiribati in 2001 to that in 2006?
Provide a short and direct response. 1.17. What is the ratio of the Pupil-teacher ratio(headcount basis) in Brunei Darussalam in 2001 to that in 2007?
Keep it short and to the point. 1.01. What is the ratio of the Pupil-teacher ratio(headcount basis) of Cambodia in 2001 to that in 2007?
Provide a succinct answer. 0.68. What is the ratio of the Pupil-teacher ratio(headcount basis) of China in 2001 to that in 2007?
Your response must be concise. 1.16. What is the ratio of the Pupil-teacher ratio(headcount basis) of Kiribati in 2001 to that in 2007?
Provide a short and direct response. 1.19. What is the ratio of the Pupil-teacher ratio(headcount basis) of Brunei Darussalam in 2002 to that in 2003?
Keep it short and to the point. 1.05. What is the ratio of the Pupil-teacher ratio(headcount basis) of Cambodia in 2002 to that in 2003?
Your answer should be very brief. 0.92. What is the ratio of the Pupil-teacher ratio(headcount basis) of China in 2002 to that in 2003?
Give a very brief answer. 1.02. What is the ratio of the Pupil-teacher ratio(headcount basis) in Kiribati in 2002 to that in 2003?
Make the answer very short. 0.92. What is the ratio of the Pupil-teacher ratio(headcount basis) of Brunei Darussalam in 2002 to that in 2006?
Offer a very short reply. 1.04. What is the ratio of the Pupil-teacher ratio(headcount basis) in Cambodia in 2002 to that in 2006?
Your response must be concise. 0.72. What is the ratio of the Pupil-teacher ratio(headcount basis) of China in 2002 to that in 2006?
Your answer should be very brief. 1.08. What is the ratio of the Pupil-teacher ratio(headcount basis) of Kiribati in 2002 to that in 2006?
Offer a very short reply. 1.02. What is the ratio of the Pupil-teacher ratio(headcount basis) of Brunei Darussalam in 2002 to that in 2007?
Your answer should be compact. 1.04. What is the ratio of the Pupil-teacher ratio(headcount basis) of Cambodia in 2002 to that in 2007?
Ensure brevity in your answer.  0.75. What is the ratio of the Pupil-teacher ratio(headcount basis) in China in 2002 to that in 2007?
Your response must be concise. 1.16. What is the ratio of the Pupil-teacher ratio(headcount basis) in Kiribati in 2002 to that in 2007?
Provide a short and direct response. 1.04. What is the ratio of the Pupil-teacher ratio(headcount basis) of Brunei Darussalam in 2003 to that in 2006?
Offer a very short reply. 0.99. What is the ratio of the Pupil-teacher ratio(headcount basis) of Cambodia in 2003 to that in 2006?
Your response must be concise. 0.79. What is the ratio of the Pupil-teacher ratio(headcount basis) of China in 2003 to that in 2006?
Your answer should be very brief. 1.06. What is the ratio of the Pupil-teacher ratio(headcount basis) of Kiribati in 2003 to that in 2006?
Your response must be concise. 1.11. What is the ratio of the Pupil-teacher ratio(headcount basis) of Cambodia in 2003 to that in 2007?
Offer a very short reply. 0.82. What is the ratio of the Pupil-teacher ratio(headcount basis) of China in 2003 to that in 2007?
Offer a very short reply. 1.14. What is the ratio of the Pupil-teacher ratio(headcount basis) in Kiribati in 2003 to that in 2007?
Your answer should be very brief. 1.13. What is the ratio of the Pupil-teacher ratio(headcount basis) of Cambodia in 2006 to that in 2007?
Offer a very short reply. 1.04. What is the ratio of the Pupil-teacher ratio(headcount basis) of China in 2006 to that in 2007?
Your answer should be very brief. 1.07. What is the ratio of the Pupil-teacher ratio(headcount basis) of Kiribati in 2006 to that in 2007?
Offer a very short reply. 1.02. What is the difference between the highest and the second highest Pupil-teacher ratio(headcount basis) of Brunei Darussalam?
Provide a short and direct response. 5.92. What is the difference between the highest and the second highest Pupil-teacher ratio(headcount basis) of Cambodia?
Your response must be concise. 1.07. What is the difference between the highest and the second highest Pupil-teacher ratio(headcount basis) in China?
Make the answer very short. 2.91. What is the difference between the highest and the second highest Pupil-teacher ratio(headcount basis) of Kiribati?
Ensure brevity in your answer.  1.07. What is the difference between the highest and the lowest Pupil-teacher ratio(headcount basis) in Brunei Darussalam?
Provide a short and direct response. 6.5. What is the difference between the highest and the lowest Pupil-teacher ratio(headcount basis) in Cambodia?
Ensure brevity in your answer.  10.42. What is the difference between the highest and the lowest Pupil-teacher ratio(headcount basis) in China?
Your answer should be very brief. 5.47. What is the difference between the highest and the lowest Pupil-teacher ratio(headcount basis) of Kiribati?
Ensure brevity in your answer.  9.16. 